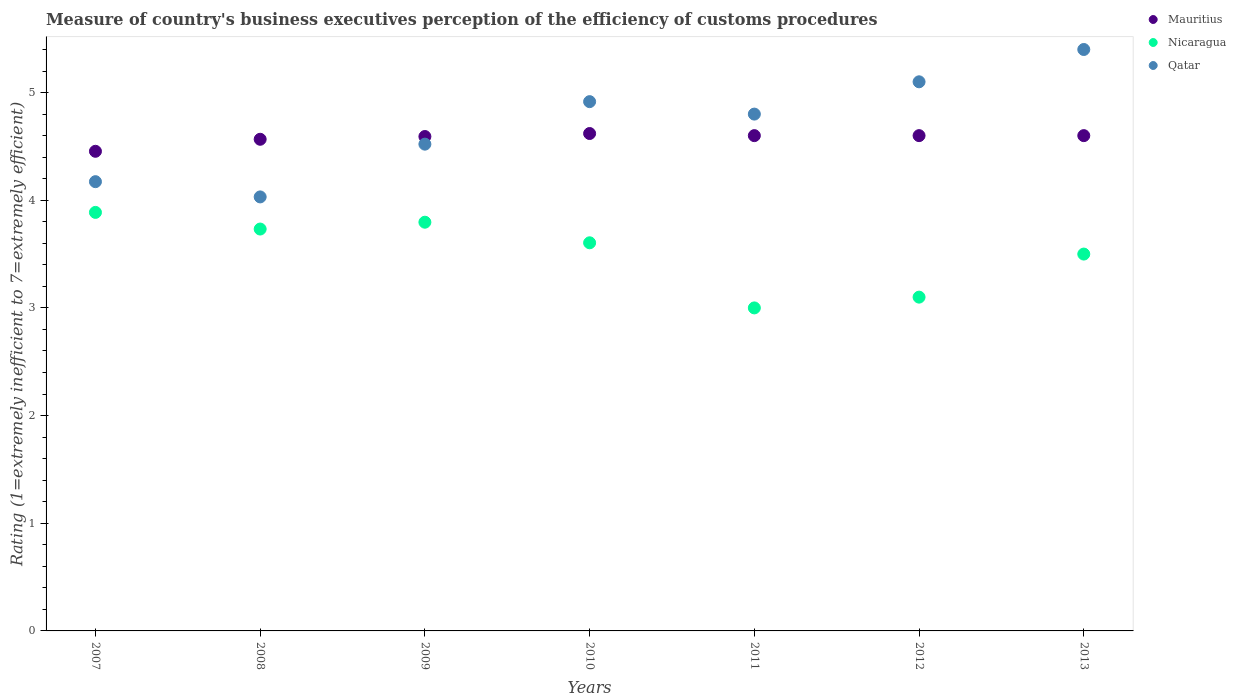Is the number of dotlines equal to the number of legend labels?
Make the answer very short. Yes. What is the rating of the efficiency of customs procedure in Mauritius in 2008?
Provide a short and direct response. 4.57. Across all years, what is the minimum rating of the efficiency of customs procedure in Mauritius?
Ensure brevity in your answer.  4.45. In which year was the rating of the efficiency of customs procedure in Nicaragua maximum?
Your response must be concise. 2007. What is the total rating of the efficiency of customs procedure in Mauritius in the graph?
Your answer should be very brief. 32.03. What is the difference between the rating of the efficiency of customs procedure in Qatar in 2009 and that in 2010?
Offer a very short reply. -0.39. What is the difference between the rating of the efficiency of customs procedure in Qatar in 2013 and the rating of the efficiency of customs procedure in Mauritius in 2009?
Keep it short and to the point. 0.81. What is the average rating of the efficiency of customs procedure in Qatar per year?
Your answer should be compact. 4.71. In the year 2009, what is the difference between the rating of the efficiency of customs procedure in Qatar and rating of the efficiency of customs procedure in Nicaragua?
Your answer should be very brief. 0.73. What is the ratio of the rating of the efficiency of customs procedure in Mauritius in 2008 to that in 2011?
Offer a very short reply. 0.99. Is the rating of the efficiency of customs procedure in Qatar in 2007 less than that in 2009?
Your response must be concise. Yes. What is the difference between the highest and the second highest rating of the efficiency of customs procedure in Mauritius?
Offer a very short reply. 0.02. What is the difference between the highest and the lowest rating of the efficiency of customs procedure in Nicaragua?
Keep it short and to the point. 0.89. In how many years, is the rating of the efficiency of customs procedure in Nicaragua greater than the average rating of the efficiency of customs procedure in Nicaragua taken over all years?
Offer a very short reply. 4. Is the sum of the rating of the efficiency of customs procedure in Mauritius in 2010 and 2013 greater than the maximum rating of the efficiency of customs procedure in Qatar across all years?
Provide a succinct answer. Yes. Does the rating of the efficiency of customs procedure in Nicaragua monotonically increase over the years?
Offer a very short reply. No. How many years are there in the graph?
Your answer should be compact. 7. Are the values on the major ticks of Y-axis written in scientific E-notation?
Your answer should be very brief. No. Does the graph contain grids?
Ensure brevity in your answer.  No. How many legend labels are there?
Give a very brief answer. 3. What is the title of the graph?
Your answer should be very brief. Measure of country's business executives perception of the efficiency of customs procedures. What is the label or title of the Y-axis?
Offer a very short reply. Rating (1=extremely inefficient to 7=extremely efficient). What is the Rating (1=extremely inefficient to 7=extremely efficient) in Mauritius in 2007?
Provide a succinct answer. 4.45. What is the Rating (1=extremely inefficient to 7=extremely efficient) of Nicaragua in 2007?
Offer a terse response. 3.89. What is the Rating (1=extremely inefficient to 7=extremely efficient) of Qatar in 2007?
Ensure brevity in your answer.  4.17. What is the Rating (1=extremely inefficient to 7=extremely efficient) of Mauritius in 2008?
Your answer should be very brief. 4.57. What is the Rating (1=extremely inefficient to 7=extremely efficient) of Nicaragua in 2008?
Your answer should be compact. 3.73. What is the Rating (1=extremely inefficient to 7=extremely efficient) of Qatar in 2008?
Provide a short and direct response. 4.03. What is the Rating (1=extremely inefficient to 7=extremely efficient) of Mauritius in 2009?
Provide a succinct answer. 4.59. What is the Rating (1=extremely inefficient to 7=extremely efficient) of Nicaragua in 2009?
Give a very brief answer. 3.8. What is the Rating (1=extremely inefficient to 7=extremely efficient) in Qatar in 2009?
Keep it short and to the point. 4.52. What is the Rating (1=extremely inefficient to 7=extremely efficient) of Mauritius in 2010?
Offer a terse response. 4.62. What is the Rating (1=extremely inefficient to 7=extremely efficient) in Nicaragua in 2010?
Give a very brief answer. 3.6. What is the Rating (1=extremely inefficient to 7=extremely efficient) of Qatar in 2010?
Keep it short and to the point. 4.92. What is the Rating (1=extremely inefficient to 7=extremely efficient) of Qatar in 2011?
Give a very brief answer. 4.8. What is the Rating (1=extremely inefficient to 7=extremely efficient) in Nicaragua in 2012?
Provide a short and direct response. 3.1. What is the Rating (1=extremely inefficient to 7=extremely efficient) of Mauritius in 2013?
Offer a very short reply. 4.6. Across all years, what is the maximum Rating (1=extremely inefficient to 7=extremely efficient) of Mauritius?
Provide a short and direct response. 4.62. Across all years, what is the maximum Rating (1=extremely inefficient to 7=extremely efficient) of Nicaragua?
Keep it short and to the point. 3.89. Across all years, what is the maximum Rating (1=extremely inefficient to 7=extremely efficient) of Qatar?
Provide a succinct answer. 5.4. Across all years, what is the minimum Rating (1=extremely inefficient to 7=extremely efficient) of Mauritius?
Provide a short and direct response. 4.45. Across all years, what is the minimum Rating (1=extremely inefficient to 7=extremely efficient) in Qatar?
Offer a very short reply. 4.03. What is the total Rating (1=extremely inefficient to 7=extremely efficient) in Mauritius in the graph?
Provide a succinct answer. 32.03. What is the total Rating (1=extremely inefficient to 7=extremely efficient) in Nicaragua in the graph?
Your answer should be compact. 24.62. What is the total Rating (1=extremely inefficient to 7=extremely efficient) of Qatar in the graph?
Keep it short and to the point. 32.94. What is the difference between the Rating (1=extremely inefficient to 7=extremely efficient) in Mauritius in 2007 and that in 2008?
Your answer should be compact. -0.11. What is the difference between the Rating (1=extremely inefficient to 7=extremely efficient) in Nicaragua in 2007 and that in 2008?
Make the answer very short. 0.15. What is the difference between the Rating (1=extremely inefficient to 7=extremely efficient) in Qatar in 2007 and that in 2008?
Give a very brief answer. 0.14. What is the difference between the Rating (1=extremely inefficient to 7=extremely efficient) in Mauritius in 2007 and that in 2009?
Your answer should be very brief. -0.14. What is the difference between the Rating (1=extremely inefficient to 7=extremely efficient) in Nicaragua in 2007 and that in 2009?
Offer a very short reply. 0.09. What is the difference between the Rating (1=extremely inefficient to 7=extremely efficient) in Qatar in 2007 and that in 2009?
Provide a short and direct response. -0.35. What is the difference between the Rating (1=extremely inefficient to 7=extremely efficient) of Mauritius in 2007 and that in 2010?
Offer a terse response. -0.17. What is the difference between the Rating (1=extremely inefficient to 7=extremely efficient) in Nicaragua in 2007 and that in 2010?
Your answer should be compact. 0.28. What is the difference between the Rating (1=extremely inefficient to 7=extremely efficient) in Qatar in 2007 and that in 2010?
Provide a short and direct response. -0.74. What is the difference between the Rating (1=extremely inefficient to 7=extremely efficient) of Mauritius in 2007 and that in 2011?
Offer a terse response. -0.15. What is the difference between the Rating (1=extremely inefficient to 7=extremely efficient) in Nicaragua in 2007 and that in 2011?
Your answer should be very brief. 0.89. What is the difference between the Rating (1=extremely inefficient to 7=extremely efficient) of Qatar in 2007 and that in 2011?
Offer a terse response. -0.63. What is the difference between the Rating (1=extremely inefficient to 7=extremely efficient) in Mauritius in 2007 and that in 2012?
Ensure brevity in your answer.  -0.15. What is the difference between the Rating (1=extremely inefficient to 7=extremely efficient) in Nicaragua in 2007 and that in 2012?
Give a very brief answer. 0.79. What is the difference between the Rating (1=extremely inefficient to 7=extremely efficient) in Qatar in 2007 and that in 2012?
Keep it short and to the point. -0.93. What is the difference between the Rating (1=extremely inefficient to 7=extremely efficient) in Mauritius in 2007 and that in 2013?
Your answer should be very brief. -0.15. What is the difference between the Rating (1=extremely inefficient to 7=extremely efficient) of Nicaragua in 2007 and that in 2013?
Your answer should be very brief. 0.39. What is the difference between the Rating (1=extremely inefficient to 7=extremely efficient) of Qatar in 2007 and that in 2013?
Make the answer very short. -1.23. What is the difference between the Rating (1=extremely inefficient to 7=extremely efficient) of Mauritius in 2008 and that in 2009?
Offer a very short reply. -0.03. What is the difference between the Rating (1=extremely inefficient to 7=extremely efficient) of Nicaragua in 2008 and that in 2009?
Your answer should be compact. -0.06. What is the difference between the Rating (1=extremely inefficient to 7=extremely efficient) of Qatar in 2008 and that in 2009?
Your answer should be very brief. -0.49. What is the difference between the Rating (1=extremely inefficient to 7=extremely efficient) in Mauritius in 2008 and that in 2010?
Provide a succinct answer. -0.05. What is the difference between the Rating (1=extremely inefficient to 7=extremely efficient) in Nicaragua in 2008 and that in 2010?
Offer a very short reply. 0.13. What is the difference between the Rating (1=extremely inefficient to 7=extremely efficient) in Qatar in 2008 and that in 2010?
Your answer should be compact. -0.88. What is the difference between the Rating (1=extremely inefficient to 7=extremely efficient) in Mauritius in 2008 and that in 2011?
Offer a terse response. -0.03. What is the difference between the Rating (1=extremely inefficient to 7=extremely efficient) in Nicaragua in 2008 and that in 2011?
Keep it short and to the point. 0.73. What is the difference between the Rating (1=extremely inefficient to 7=extremely efficient) of Qatar in 2008 and that in 2011?
Keep it short and to the point. -0.77. What is the difference between the Rating (1=extremely inefficient to 7=extremely efficient) in Mauritius in 2008 and that in 2012?
Your response must be concise. -0.03. What is the difference between the Rating (1=extremely inefficient to 7=extremely efficient) in Nicaragua in 2008 and that in 2012?
Offer a very short reply. 0.63. What is the difference between the Rating (1=extremely inefficient to 7=extremely efficient) of Qatar in 2008 and that in 2012?
Offer a terse response. -1.07. What is the difference between the Rating (1=extremely inefficient to 7=extremely efficient) of Mauritius in 2008 and that in 2013?
Make the answer very short. -0.03. What is the difference between the Rating (1=extremely inefficient to 7=extremely efficient) in Nicaragua in 2008 and that in 2013?
Your response must be concise. 0.23. What is the difference between the Rating (1=extremely inefficient to 7=extremely efficient) in Qatar in 2008 and that in 2013?
Your response must be concise. -1.37. What is the difference between the Rating (1=extremely inefficient to 7=extremely efficient) in Mauritius in 2009 and that in 2010?
Ensure brevity in your answer.  -0.03. What is the difference between the Rating (1=extremely inefficient to 7=extremely efficient) in Nicaragua in 2009 and that in 2010?
Offer a very short reply. 0.19. What is the difference between the Rating (1=extremely inefficient to 7=extremely efficient) of Qatar in 2009 and that in 2010?
Your response must be concise. -0.39. What is the difference between the Rating (1=extremely inefficient to 7=extremely efficient) of Mauritius in 2009 and that in 2011?
Your response must be concise. -0.01. What is the difference between the Rating (1=extremely inefficient to 7=extremely efficient) in Nicaragua in 2009 and that in 2011?
Give a very brief answer. 0.8. What is the difference between the Rating (1=extremely inefficient to 7=extremely efficient) of Qatar in 2009 and that in 2011?
Your answer should be very brief. -0.28. What is the difference between the Rating (1=extremely inefficient to 7=extremely efficient) of Mauritius in 2009 and that in 2012?
Ensure brevity in your answer.  -0.01. What is the difference between the Rating (1=extremely inefficient to 7=extremely efficient) in Nicaragua in 2009 and that in 2012?
Your response must be concise. 0.7. What is the difference between the Rating (1=extremely inefficient to 7=extremely efficient) of Qatar in 2009 and that in 2012?
Provide a succinct answer. -0.58. What is the difference between the Rating (1=extremely inefficient to 7=extremely efficient) in Mauritius in 2009 and that in 2013?
Your answer should be very brief. -0.01. What is the difference between the Rating (1=extremely inefficient to 7=extremely efficient) of Nicaragua in 2009 and that in 2013?
Make the answer very short. 0.3. What is the difference between the Rating (1=extremely inefficient to 7=extremely efficient) of Qatar in 2009 and that in 2013?
Offer a terse response. -0.88. What is the difference between the Rating (1=extremely inefficient to 7=extremely efficient) of Mauritius in 2010 and that in 2011?
Offer a very short reply. 0.02. What is the difference between the Rating (1=extremely inefficient to 7=extremely efficient) in Nicaragua in 2010 and that in 2011?
Make the answer very short. 0.6. What is the difference between the Rating (1=extremely inefficient to 7=extremely efficient) in Qatar in 2010 and that in 2011?
Provide a short and direct response. 0.12. What is the difference between the Rating (1=extremely inefficient to 7=extremely efficient) of Mauritius in 2010 and that in 2012?
Offer a terse response. 0.02. What is the difference between the Rating (1=extremely inefficient to 7=extremely efficient) of Nicaragua in 2010 and that in 2012?
Provide a succinct answer. 0.5. What is the difference between the Rating (1=extremely inefficient to 7=extremely efficient) of Qatar in 2010 and that in 2012?
Make the answer very short. -0.18. What is the difference between the Rating (1=extremely inefficient to 7=extremely efficient) in Mauritius in 2010 and that in 2013?
Your answer should be very brief. 0.02. What is the difference between the Rating (1=extremely inefficient to 7=extremely efficient) in Nicaragua in 2010 and that in 2013?
Your answer should be very brief. 0.1. What is the difference between the Rating (1=extremely inefficient to 7=extremely efficient) in Qatar in 2010 and that in 2013?
Keep it short and to the point. -0.48. What is the difference between the Rating (1=extremely inefficient to 7=extremely efficient) in Nicaragua in 2011 and that in 2012?
Give a very brief answer. -0.1. What is the difference between the Rating (1=extremely inefficient to 7=extremely efficient) of Qatar in 2011 and that in 2012?
Your answer should be very brief. -0.3. What is the difference between the Rating (1=extremely inefficient to 7=extremely efficient) of Mauritius in 2011 and that in 2013?
Provide a short and direct response. 0. What is the difference between the Rating (1=extremely inefficient to 7=extremely efficient) in Mauritius in 2007 and the Rating (1=extremely inefficient to 7=extremely efficient) in Nicaragua in 2008?
Make the answer very short. 0.72. What is the difference between the Rating (1=extremely inefficient to 7=extremely efficient) in Mauritius in 2007 and the Rating (1=extremely inefficient to 7=extremely efficient) in Qatar in 2008?
Your answer should be very brief. 0.42. What is the difference between the Rating (1=extremely inefficient to 7=extremely efficient) in Nicaragua in 2007 and the Rating (1=extremely inefficient to 7=extremely efficient) in Qatar in 2008?
Provide a short and direct response. -0.14. What is the difference between the Rating (1=extremely inefficient to 7=extremely efficient) of Mauritius in 2007 and the Rating (1=extremely inefficient to 7=extremely efficient) of Nicaragua in 2009?
Your answer should be compact. 0.66. What is the difference between the Rating (1=extremely inefficient to 7=extremely efficient) in Mauritius in 2007 and the Rating (1=extremely inefficient to 7=extremely efficient) in Qatar in 2009?
Give a very brief answer. -0.07. What is the difference between the Rating (1=extremely inefficient to 7=extremely efficient) of Nicaragua in 2007 and the Rating (1=extremely inefficient to 7=extremely efficient) of Qatar in 2009?
Offer a terse response. -0.63. What is the difference between the Rating (1=extremely inefficient to 7=extremely efficient) of Mauritius in 2007 and the Rating (1=extremely inefficient to 7=extremely efficient) of Nicaragua in 2010?
Offer a terse response. 0.85. What is the difference between the Rating (1=extremely inefficient to 7=extremely efficient) of Mauritius in 2007 and the Rating (1=extremely inefficient to 7=extremely efficient) of Qatar in 2010?
Your answer should be very brief. -0.46. What is the difference between the Rating (1=extremely inefficient to 7=extremely efficient) in Nicaragua in 2007 and the Rating (1=extremely inefficient to 7=extremely efficient) in Qatar in 2010?
Provide a succinct answer. -1.03. What is the difference between the Rating (1=extremely inefficient to 7=extremely efficient) of Mauritius in 2007 and the Rating (1=extremely inefficient to 7=extremely efficient) of Nicaragua in 2011?
Make the answer very short. 1.45. What is the difference between the Rating (1=extremely inefficient to 7=extremely efficient) in Mauritius in 2007 and the Rating (1=extremely inefficient to 7=extremely efficient) in Qatar in 2011?
Offer a very short reply. -0.35. What is the difference between the Rating (1=extremely inefficient to 7=extremely efficient) of Nicaragua in 2007 and the Rating (1=extremely inefficient to 7=extremely efficient) of Qatar in 2011?
Make the answer very short. -0.91. What is the difference between the Rating (1=extremely inefficient to 7=extremely efficient) in Mauritius in 2007 and the Rating (1=extremely inefficient to 7=extremely efficient) in Nicaragua in 2012?
Ensure brevity in your answer.  1.35. What is the difference between the Rating (1=extremely inefficient to 7=extremely efficient) in Mauritius in 2007 and the Rating (1=extremely inefficient to 7=extremely efficient) in Qatar in 2012?
Keep it short and to the point. -0.65. What is the difference between the Rating (1=extremely inefficient to 7=extremely efficient) in Nicaragua in 2007 and the Rating (1=extremely inefficient to 7=extremely efficient) in Qatar in 2012?
Give a very brief answer. -1.21. What is the difference between the Rating (1=extremely inefficient to 7=extremely efficient) of Mauritius in 2007 and the Rating (1=extremely inefficient to 7=extremely efficient) of Nicaragua in 2013?
Keep it short and to the point. 0.95. What is the difference between the Rating (1=extremely inefficient to 7=extremely efficient) in Mauritius in 2007 and the Rating (1=extremely inefficient to 7=extremely efficient) in Qatar in 2013?
Keep it short and to the point. -0.95. What is the difference between the Rating (1=extremely inefficient to 7=extremely efficient) of Nicaragua in 2007 and the Rating (1=extremely inefficient to 7=extremely efficient) of Qatar in 2013?
Offer a very short reply. -1.51. What is the difference between the Rating (1=extremely inefficient to 7=extremely efficient) of Mauritius in 2008 and the Rating (1=extremely inefficient to 7=extremely efficient) of Nicaragua in 2009?
Provide a succinct answer. 0.77. What is the difference between the Rating (1=extremely inefficient to 7=extremely efficient) of Mauritius in 2008 and the Rating (1=extremely inefficient to 7=extremely efficient) of Qatar in 2009?
Provide a succinct answer. 0.05. What is the difference between the Rating (1=extremely inefficient to 7=extremely efficient) in Nicaragua in 2008 and the Rating (1=extremely inefficient to 7=extremely efficient) in Qatar in 2009?
Offer a very short reply. -0.79. What is the difference between the Rating (1=extremely inefficient to 7=extremely efficient) in Mauritius in 2008 and the Rating (1=extremely inefficient to 7=extremely efficient) in Nicaragua in 2010?
Offer a terse response. 0.96. What is the difference between the Rating (1=extremely inefficient to 7=extremely efficient) of Mauritius in 2008 and the Rating (1=extremely inefficient to 7=extremely efficient) of Qatar in 2010?
Provide a succinct answer. -0.35. What is the difference between the Rating (1=extremely inefficient to 7=extremely efficient) in Nicaragua in 2008 and the Rating (1=extremely inefficient to 7=extremely efficient) in Qatar in 2010?
Keep it short and to the point. -1.18. What is the difference between the Rating (1=extremely inefficient to 7=extremely efficient) of Mauritius in 2008 and the Rating (1=extremely inefficient to 7=extremely efficient) of Nicaragua in 2011?
Provide a succinct answer. 1.57. What is the difference between the Rating (1=extremely inefficient to 7=extremely efficient) in Mauritius in 2008 and the Rating (1=extremely inefficient to 7=extremely efficient) in Qatar in 2011?
Ensure brevity in your answer.  -0.23. What is the difference between the Rating (1=extremely inefficient to 7=extremely efficient) in Nicaragua in 2008 and the Rating (1=extremely inefficient to 7=extremely efficient) in Qatar in 2011?
Your response must be concise. -1.07. What is the difference between the Rating (1=extremely inefficient to 7=extremely efficient) in Mauritius in 2008 and the Rating (1=extremely inefficient to 7=extremely efficient) in Nicaragua in 2012?
Ensure brevity in your answer.  1.47. What is the difference between the Rating (1=extremely inefficient to 7=extremely efficient) of Mauritius in 2008 and the Rating (1=extremely inefficient to 7=extremely efficient) of Qatar in 2012?
Give a very brief answer. -0.53. What is the difference between the Rating (1=extremely inefficient to 7=extremely efficient) in Nicaragua in 2008 and the Rating (1=extremely inefficient to 7=extremely efficient) in Qatar in 2012?
Make the answer very short. -1.37. What is the difference between the Rating (1=extremely inefficient to 7=extremely efficient) in Mauritius in 2008 and the Rating (1=extremely inefficient to 7=extremely efficient) in Nicaragua in 2013?
Make the answer very short. 1.07. What is the difference between the Rating (1=extremely inefficient to 7=extremely efficient) of Mauritius in 2008 and the Rating (1=extremely inefficient to 7=extremely efficient) of Qatar in 2013?
Your answer should be very brief. -0.83. What is the difference between the Rating (1=extremely inefficient to 7=extremely efficient) in Nicaragua in 2008 and the Rating (1=extremely inefficient to 7=extremely efficient) in Qatar in 2013?
Your response must be concise. -1.67. What is the difference between the Rating (1=extremely inefficient to 7=extremely efficient) of Mauritius in 2009 and the Rating (1=extremely inefficient to 7=extremely efficient) of Qatar in 2010?
Ensure brevity in your answer.  -0.32. What is the difference between the Rating (1=extremely inefficient to 7=extremely efficient) of Nicaragua in 2009 and the Rating (1=extremely inefficient to 7=extremely efficient) of Qatar in 2010?
Provide a succinct answer. -1.12. What is the difference between the Rating (1=extremely inefficient to 7=extremely efficient) in Mauritius in 2009 and the Rating (1=extremely inefficient to 7=extremely efficient) in Nicaragua in 2011?
Give a very brief answer. 1.59. What is the difference between the Rating (1=extremely inefficient to 7=extremely efficient) of Mauritius in 2009 and the Rating (1=extremely inefficient to 7=extremely efficient) of Qatar in 2011?
Ensure brevity in your answer.  -0.21. What is the difference between the Rating (1=extremely inefficient to 7=extremely efficient) of Nicaragua in 2009 and the Rating (1=extremely inefficient to 7=extremely efficient) of Qatar in 2011?
Offer a very short reply. -1. What is the difference between the Rating (1=extremely inefficient to 7=extremely efficient) of Mauritius in 2009 and the Rating (1=extremely inefficient to 7=extremely efficient) of Nicaragua in 2012?
Offer a terse response. 1.49. What is the difference between the Rating (1=extremely inefficient to 7=extremely efficient) in Mauritius in 2009 and the Rating (1=extremely inefficient to 7=extremely efficient) in Qatar in 2012?
Provide a short and direct response. -0.51. What is the difference between the Rating (1=extremely inefficient to 7=extremely efficient) of Nicaragua in 2009 and the Rating (1=extremely inefficient to 7=extremely efficient) of Qatar in 2012?
Give a very brief answer. -1.3. What is the difference between the Rating (1=extremely inefficient to 7=extremely efficient) in Mauritius in 2009 and the Rating (1=extremely inefficient to 7=extremely efficient) in Nicaragua in 2013?
Keep it short and to the point. 1.09. What is the difference between the Rating (1=extremely inefficient to 7=extremely efficient) in Mauritius in 2009 and the Rating (1=extremely inefficient to 7=extremely efficient) in Qatar in 2013?
Ensure brevity in your answer.  -0.81. What is the difference between the Rating (1=extremely inefficient to 7=extremely efficient) of Nicaragua in 2009 and the Rating (1=extremely inefficient to 7=extremely efficient) of Qatar in 2013?
Offer a terse response. -1.6. What is the difference between the Rating (1=extremely inefficient to 7=extremely efficient) of Mauritius in 2010 and the Rating (1=extremely inefficient to 7=extremely efficient) of Nicaragua in 2011?
Ensure brevity in your answer.  1.62. What is the difference between the Rating (1=extremely inefficient to 7=extremely efficient) in Mauritius in 2010 and the Rating (1=extremely inefficient to 7=extremely efficient) in Qatar in 2011?
Provide a short and direct response. -0.18. What is the difference between the Rating (1=extremely inefficient to 7=extremely efficient) of Nicaragua in 2010 and the Rating (1=extremely inefficient to 7=extremely efficient) of Qatar in 2011?
Make the answer very short. -1.2. What is the difference between the Rating (1=extremely inefficient to 7=extremely efficient) of Mauritius in 2010 and the Rating (1=extremely inefficient to 7=extremely efficient) of Nicaragua in 2012?
Ensure brevity in your answer.  1.52. What is the difference between the Rating (1=extremely inefficient to 7=extremely efficient) in Mauritius in 2010 and the Rating (1=extremely inefficient to 7=extremely efficient) in Qatar in 2012?
Offer a terse response. -0.48. What is the difference between the Rating (1=extremely inefficient to 7=extremely efficient) in Nicaragua in 2010 and the Rating (1=extremely inefficient to 7=extremely efficient) in Qatar in 2012?
Keep it short and to the point. -1.5. What is the difference between the Rating (1=extremely inefficient to 7=extremely efficient) of Mauritius in 2010 and the Rating (1=extremely inefficient to 7=extremely efficient) of Nicaragua in 2013?
Give a very brief answer. 1.12. What is the difference between the Rating (1=extremely inefficient to 7=extremely efficient) in Mauritius in 2010 and the Rating (1=extremely inefficient to 7=extremely efficient) in Qatar in 2013?
Keep it short and to the point. -0.78. What is the difference between the Rating (1=extremely inefficient to 7=extremely efficient) of Nicaragua in 2010 and the Rating (1=extremely inefficient to 7=extremely efficient) of Qatar in 2013?
Provide a short and direct response. -1.8. What is the difference between the Rating (1=extremely inefficient to 7=extremely efficient) in Nicaragua in 2011 and the Rating (1=extremely inefficient to 7=extremely efficient) in Qatar in 2012?
Your answer should be compact. -2.1. What is the difference between the Rating (1=extremely inefficient to 7=extremely efficient) in Mauritius in 2011 and the Rating (1=extremely inefficient to 7=extremely efficient) in Nicaragua in 2013?
Offer a very short reply. 1.1. What is the difference between the Rating (1=extremely inefficient to 7=extremely efficient) of Nicaragua in 2011 and the Rating (1=extremely inefficient to 7=extremely efficient) of Qatar in 2013?
Keep it short and to the point. -2.4. What is the difference between the Rating (1=extremely inefficient to 7=extremely efficient) in Mauritius in 2012 and the Rating (1=extremely inefficient to 7=extremely efficient) in Nicaragua in 2013?
Your answer should be compact. 1.1. What is the average Rating (1=extremely inefficient to 7=extremely efficient) in Mauritius per year?
Keep it short and to the point. 4.58. What is the average Rating (1=extremely inefficient to 7=extremely efficient) of Nicaragua per year?
Your answer should be very brief. 3.52. What is the average Rating (1=extremely inefficient to 7=extremely efficient) in Qatar per year?
Provide a succinct answer. 4.71. In the year 2007, what is the difference between the Rating (1=extremely inefficient to 7=extremely efficient) in Mauritius and Rating (1=extremely inefficient to 7=extremely efficient) in Nicaragua?
Provide a short and direct response. 0.57. In the year 2007, what is the difference between the Rating (1=extremely inefficient to 7=extremely efficient) of Mauritius and Rating (1=extremely inefficient to 7=extremely efficient) of Qatar?
Provide a succinct answer. 0.28. In the year 2007, what is the difference between the Rating (1=extremely inefficient to 7=extremely efficient) of Nicaragua and Rating (1=extremely inefficient to 7=extremely efficient) of Qatar?
Provide a short and direct response. -0.29. In the year 2008, what is the difference between the Rating (1=extremely inefficient to 7=extremely efficient) of Mauritius and Rating (1=extremely inefficient to 7=extremely efficient) of Nicaragua?
Your answer should be compact. 0.83. In the year 2008, what is the difference between the Rating (1=extremely inefficient to 7=extremely efficient) of Mauritius and Rating (1=extremely inefficient to 7=extremely efficient) of Qatar?
Give a very brief answer. 0.54. In the year 2008, what is the difference between the Rating (1=extremely inefficient to 7=extremely efficient) in Nicaragua and Rating (1=extremely inefficient to 7=extremely efficient) in Qatar?
Offer a terse response. -0.3. In the year 2009, what is the difference between the Rating (1=extremely inefficient to 7=extremely efficient) of Mauritius and Rating (1=extremely inefficient to 7=extremely efficient) of Nicaragua?
Ensure brevity in your answer.  0.8. In the year 2009, what is the difference between the Rating (1=extremely inefficient to 7=extremely efficient) in Mauritius and Rating (1=extremely inefficient to 7=extremely efficient) in Qatar?
Give a very brief answer. 0.07. In the year 2009, what is the difference between the Rating (1=extremely inefficient to 7=extremely efficient) in Nicaragua and Rating (1=extremely inefficient to 7=extremely efficient) in Qatar?
Offer a terse response. -0.72. In the year 2010, what is the difference between the Rating (1=extremely inefficient to 7=extremely efficient) in Mauritius and Rating (1=extremely inefficient to 7=extremely efficient) in Nicaragua?
Your answer should be very brief. 1.01. In the year 2010, what is the difference between the Rating (1=extremely inefficient to 7=extremely efficient) of Mauritius and Rating (1=extremely inefficient to 7=extremely efficient) of Qatar?
Keep it short and to the point. -0.3. In the year 2010, what is the difference between the Rating (1=extremely inefficient to 7=extremely efficient) in Nicaragua and Rating (1=extremely inefficient to 7=extremely efficient) in Qatar?
Ensure brevity in your answer.  -1.31. In the year 2012, what is the difference between the Rating (1=extremely inefficient to 7=extremely efficient) in Mauritius and Rating (1=extremely inefficient to 7=extremely efficient) in Nicaragua?
Make the answer very short. 1.5. In the year 2012, what is the difference between the Rating (1=extremely inefficient to 7=extremely efficient) of Mauritius and Rating (1=extremely inefficient to 7=extremely efficient) of Qatar?
Keep it short and to the point. -0.5. In the year 2012, what is the difference between the Rating (1=extremely inefficient to 7=extremely efficient) in Nicaragua and Rating (1=extremely inefficient to 7=extremely efficient) in Qatar?
Offer a very short reply. -2. In the year 2013, what is the difference between the Rating (1=extremely inefficient to 7=extremely efficient) in Nicaragua and Rating (1=extremely inefficient to 7=extremely efficient) in Qatar?
Your response must be concise. -1.9. What is the ratio of the Rating (1=extremely inefficient to 7=extremely efficient) in Mauritius in 2007 to that in 2008?
Provide a short and direct response. 0.98. What is the ratio of the Rating (1=extremely inefficient to 7=extremely efficient) of Nicaragua in 2007 to that in 2008?
Give a very brief answer. 1.04. What is the ratio of the Rating (1=extremely inefficient to 7=extremely efficient) in Qatar in 2007 to that in 2008?
Your answer should be very brief. 1.04. What is the ratio of the Rating (1=extremely inefficient to 7=extremely efficient) in Mauritius in 2007 to that in 2009?
Ensure brevity in your answer.  0.97. What is the ratio of the Rating (1=extremely inefficient to 7=extremely efficient) in Qatar in 2007 to that in 2009?
Your answer should be very brief. 0.92. What is the ratio of the Rating (1=extremely inefficient to 7=extremely efficient) in Mauritius in 2007 to that in 2010?
Your answer should be compact. 0.96. What is the ratio of the Rating (1=extremely inefficient to 7=extremely efficient) of Nicaragua in 2007 to that in 2010?
Your answer should be very brief. 1.08. What is the ratio of the Rating (1=extremely inefficient to 7=extremely efficient) of Qatar in 2007 to that in 2010?
Your answer should be compact. 0.85. What is the ratio of the Rating (1=extremely inefficient to 7=extremely efficient) in Mauritius in 2007 to that in 2011?
Give a very brief answer. 0.97. What is the ratio of the Rating (1=extremely inefficient to 7=extremely efficient) of Nicaragua in 2007 to that in 2011?
Your answer should be very brief. 1.3. What is the ratio of the Rating (1=extremely inefficient to 7=extremely efficient) of Qatar in 2007 to that in 2011?
Ensure brevity in your answer.  0.87. What is the ratio of the Rating (1=extremely inefficient to 7=extremely efficient) in Mauritius in 2007 to that in 2012?
Your answer should be very brief. 0.97. What is the ratio of the Rating (1=extremely inefficient to 7=extremely efficient) in Nicaragua in 2007 to that in 2012?
Your answer should be compact. 1.25. What is the ratio of the Rating (1=extremely inefficient to 7=extremely efficient) of Qatar in 2007 to that in 2012?
Provide a short and direct response. 0.82. What is the ratio of the Rating (1=extremely inefficient to 7=extremely efficient) of Mauritius in 2007 to that in 2013?
Provide a succinct answer. 0.97. What is the ratio of the Rating (1=extremely inefficient to 7=extremely efficient) of Nicaragua in 2007 to that in 2013?
Ensure brevity in your answer.  1.11. What is the ratio of the Rating (1=extremely inefficient to 7=extremely efficient) of Qatar in 2007 to that in 2013?
Your answer should be compact. 0.77. What is the ratio of the Rating (1=extremely inefficient to 7=extremely efficient) of Nicaragua in 2008 to that in 2009?
Ensure brevity in your answer.  0.98. What is the ratio of the Rating (1=extremely inefficient to 7=extremely efficient) in Qatar in 2008 to that in 2009?
Your answer should be compact. 0.89. What is the ratio of the Rating (1=extremely inefficient to 7=extremely efficient) of Mauritius in 2008 to that in 2010?
Make the answer very short. 0.99. What is the ratio of the Rating (1=extremely inefficient to 7=extremely efficient) in Nicaragua in 2008 to that in 2010?
Offer a terse response. 1.04. What is the ratio of the Rating (1=extremely inefficient to 7=extremely efficient) of Qatar in 2008 to that in 2010?
Offer a very short reply. 0.82. What is the ratio of the Rating (1=extremely inefficient to 7=extremely efficient) in Nicaragua in 2008 to that in 2011?
Your response must be concise. 1.24. What is the ratio of the Rating (1=extremely inefficient to 7=extremely efficient) of Qatar in 2008 to that in 2011?
Give a very brief answer. 0.84. What is the ratio of the Rating (1=extremely inefficient to 7=extremely efficient) in Nicaragua in 2008 to that in 2012?
Your answer should be compact. 1.2. What is the ratio of the Rating (1=extremely inefficient to 7=extremely efficient) of Qatar in 2008 to that in 2012?
Keep it short and to the point. 0.79. What is the ratio of the Rating (1=extremely inefficient to 7=extremely efficient) in Nicaragua in 2008 to that in 2013?
Provide a short and direct response. 1.07. What is the ratio of the Rating (1=extremely inefficient to 7=extremely efficient) in Qatar in 2008 to that in 2013?
Ensure brevity in your answer.  0.75. What is the ratio of the Rating (1=extremely inefficient to 7=extremely efficient) in Mauritius in 2009 to that in 2010?
Your answer should be very brief. 0.99. What is the ratio of the Rating (1=extremely inefficient to 7=extremely efficient) in Nicaragua in 2009 to that in 2010?
Offer a very short reply. 1.05. What is the ratio of the Rating (1=extremely inefficient to 7=extremely efficient) of Qatar in 2009 to that in 2010?
Offer a terse response. 0.92. What is the ratio of the Rating (1=extremely inefficient to 7=extremely efficient) in Mauritius in 2009 to that in 2011?
Your response must be concise. 1. What is the ratio of the Rating (1=extremely inefficient to 7=extremely efficient) of Nicaragua in 2009 to that in 2011?
Provide a succinct answer. 1.27. What is the ratio of the Rating (1=extremely inefficient to 7=extremely efficient) of Qatar in 2009 to that in 2011?
Give a very brief answer. 0.94. What is the ratio of the Rating (1=extremely inefficient to 7=extremely efficient) in Mauritius in 2009 to that in 2012?
Provide a succinct answer. 1. What is the ratio of the Rating (1=extremely inefficient to 7=extremely efficient) of Nicaragua in 2009 to that in 2012?
Provide a short and direct response. 1.22. What is the ratio of the Rating (1=extremely inefficient to 7=extremely efficient) of Qatar in 2009 to that in 2012?
Give a very brief answer. 0.89. What is the ratio of the Rating (1=extremely inefficient to 7=extremely efficient) of Nicaragua in 2009 to that in 2013?
Ensure brevity in your answer.  1.08. What is the ratio of the Rating (1=extremely inefficient to 7=extremely efficient) of Qatar in 2009 to that in 2013?
Your response must be concise. 0.84. What is the ratio of the Rating (1=extremely inefficient to 7=extremely efficient) in Nicaragua in 2010 to that in 2011?
Provide a short and direct response. 1.2. What is the ratio of the Rating (1=extremely inefficient to 7=extremely efficient) in Qatar in 2010 to that in 2011?
Ensure brevity in your answer.  1.02. What is the ratio of the Rating (1=extremely inefficient to 7=extremely efficient) of Nicaragua in 2010 to that in 2012?
Provide a succinct answer. 1.16. What is the ratio of the Rating (1=extremely inefficient to 7=extremely efficient) of Qatar in 2010 to that in 2012?
Provide a short and direct response. 0.96. What is the ratio of the Rating (1=extremely inefficient to 7=extremely efficient) in Nicaragua in 2010 to that in 2013?
Your answer should be very brief. 1.03. What is the ratio of the Rating (1=extremely inefficient to 7=extremely efficient) of Qatar in 2010 to that in 2013?
Offer a very short reply. 0.91. What is the ratio of the Rating (1=extremely inefficient to 7=extremely efficient) in Qatar in 2011 to that in 2012?
Ensure brevity in your answer.  0.94. What is the ratio of the Rating (1=extremely inefficient to 7=extremely efficient) in Mauritius in 2011 to that in 2013?
Your answer should be very brief. 1. What is the ratio of the Rating (1=extremely inefficient to 7=extremely efficient) in Nicaragua in 2011 to that in 2013?
Provide a short and direct response. 0.86. What is the ratio of the Rating (1=extremely inefficient to 7=extremely efficient) in Qatar in 2011 to that in 2013?
Make the answer very short. 0.89. What is the ratio of the Rating (1=extremely inefficient to 7=extremely efficient) of Mauritius in 2012 to that in 2013?
Your response must be concise. 1. What is the ratio of the Rating (1=extremely inefficient to 7=extremely efficient) of Nicaragua in 2012 to that in 2013?
Your response must be concise. 0.89. What is the difference between the highest and the second highest Rating (1=extremely inefficient to 7=extremely efficient) of Mauritius?
Give a very brief answer. 0.02. What is the difference between the highest and the second highest Rating (1=extremely inefficient to 7=extremely efficient) of Nicaragua?
Provide a short and direct response. 0.09. What is the difference between the highest and the second highest Rating (1=extremely inefficient to 7=extremely efficient) of Qatar?
Provide a succinct answer. 0.3. What is the difference between the highest and the lowest Rating (1=extremely inefficient to 7=extremely efficient) in Mauritius?
Provide a short and direct response. 0.17. What is the difference between the highest and the lowest Rating (1=extremely inefficient to 7=extremely efficient) of Nicaragua?
Offer a very short reply. 0.89. What is the difference between the highest and the lowest Rating (1=extremely inefficient to 7=extremely efficient) in Qatar?
Your answer should be very brief. 1.37. 